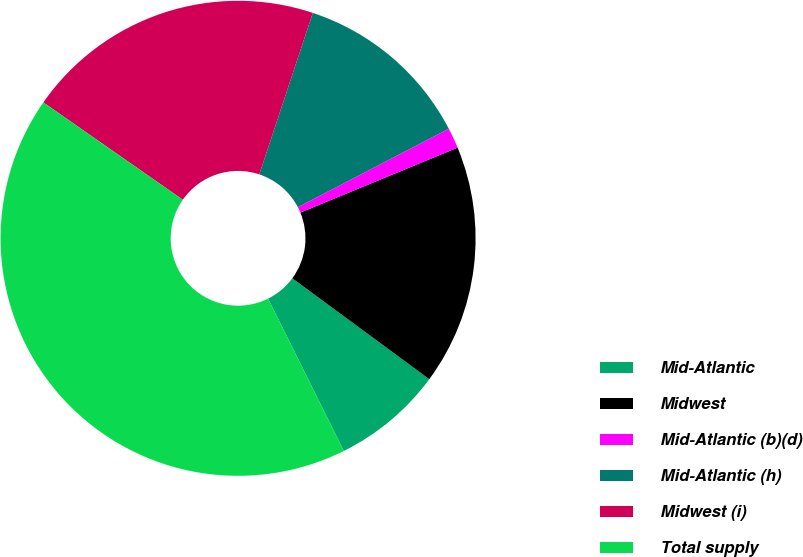<chart> <loc_0><loc_0><loc_500><loc_500><pie_chart><fcel>Mid-Atlantic<fcel>Midwest<fcel>Mid-Atlantic (b)(d)<fcel>Mid-Atlantic (h)<fcel>Midwest (i)<fcel>Total supply<nl><fcel>7.55%<fcel>16.34%<fcel>1.4%<fcel>12.27%<fcel>20.4%<fcel>42.04%<nl></chart> 